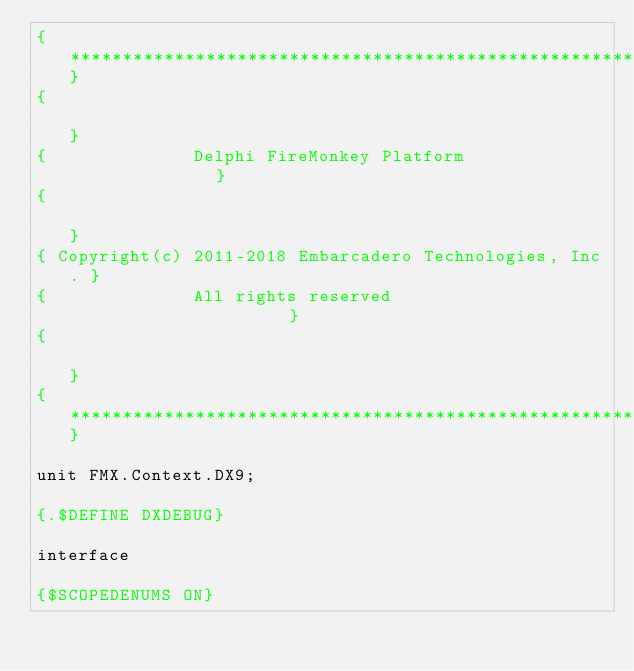<code> <loc_0><loc_0><loc_500><loc_500><_Pascal_>{*******************************************************}
{                                                       }
{              Delphi FireMonkey Platform               }
{                                                       }
{ Copyright(c) 2011-2018 Embarcadero Technologies, Inc. }
{              All rights reserved                      }
{                                                       }
{*******************************************************}

unit FMX.Context.DX9;

{.$DEFINE DXDEBUG}

interface

{$SCOPEDENUMS ON}
</code> 